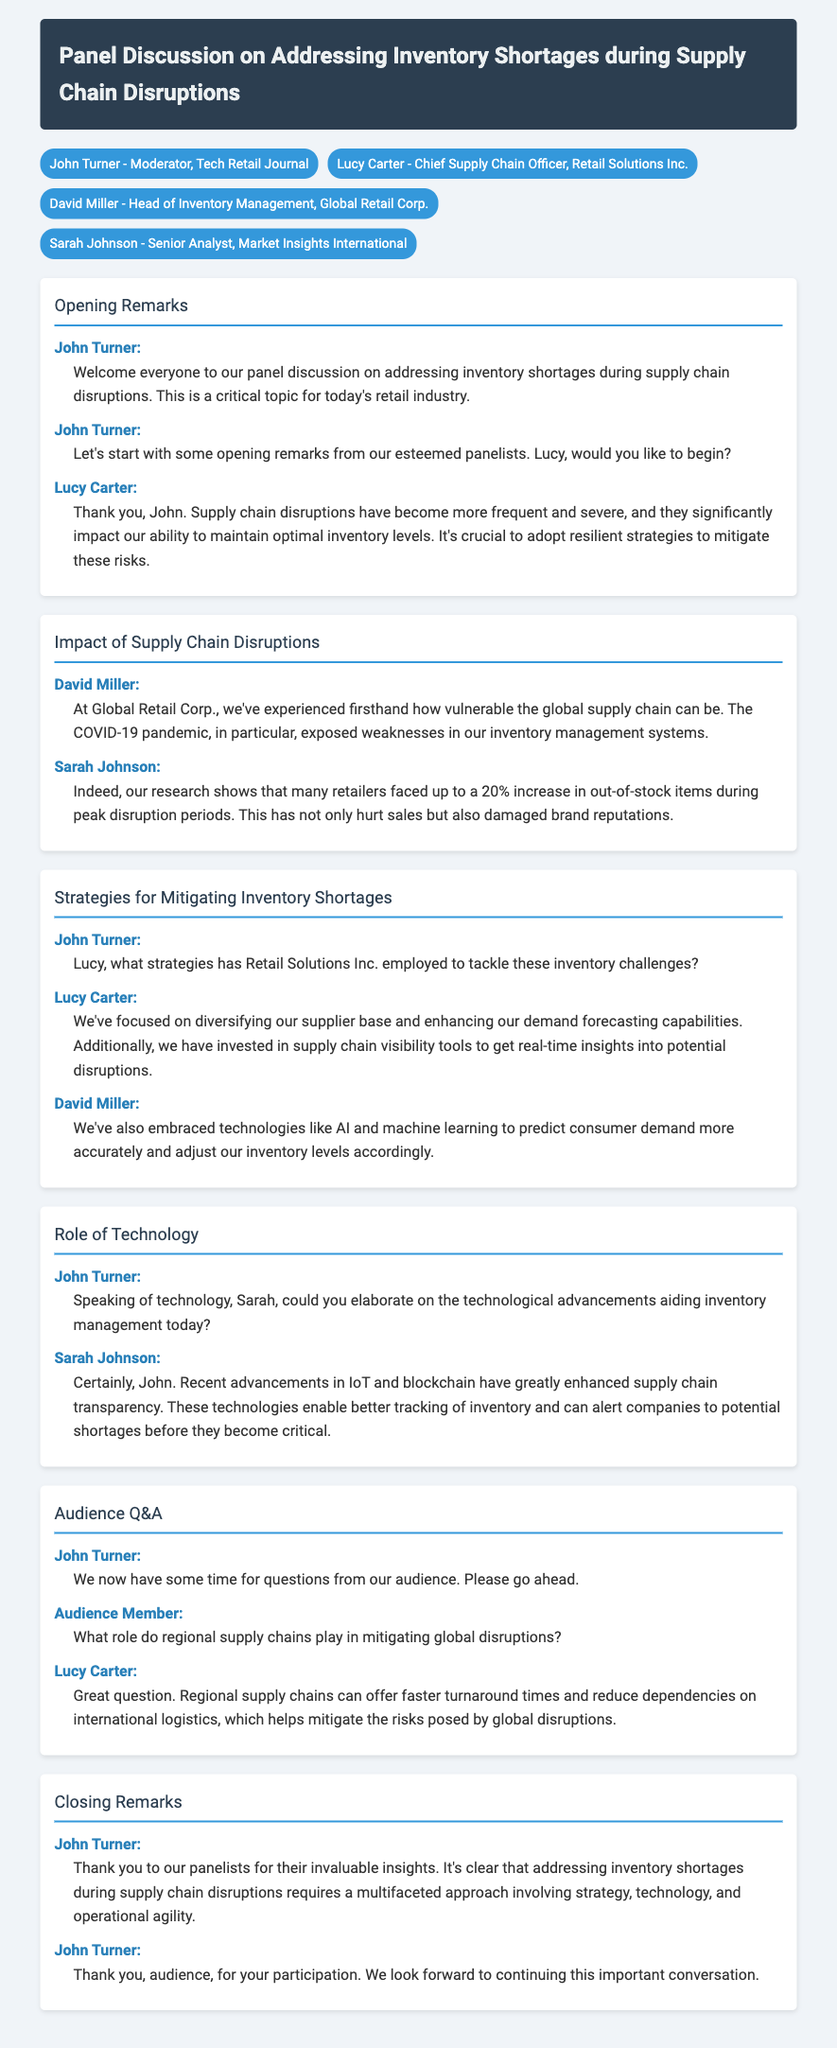What is the title of the panel discussion? The title is mentioned at the top of the document in the header section.
Answer: Panel Discussion on Addressing Inventory Shortages during Supply Chain Disruptions Who is the moderator of the panel discussion? The moderator is introduced in the participants section.
Answer: John Turner What percentage increase in out-of-stock items did retailers face? This information is provided by Sarah Johnson during the discussion on the impact of supply chain disruptions.
Answer: 20% Which company does Lucy Carter represent? Lucy introduces herself during the opening remarks, indicating her affiliation.
Answer: Retail Solutions Inc What technology has Retail Solutions Inc. invested in? Lucy Carter explains their focus areas, including specific technologies in her dialogue.
Answer: Supply chain visibility tools What role do regional supply chains play according to Lucy Carter? This is discussed during the audience Q&A section.
Answer: Faster turnaround times What has been embraced by Global Retail Corp. to predict consumer demand? David Miller mentions this specific approach during the strategies section.
Answer: AI and machine learning Which technologies enable better tracking of inventory? Sarah Johnson discusses this during the role of technology section.
Answer: IoT and blockchain 